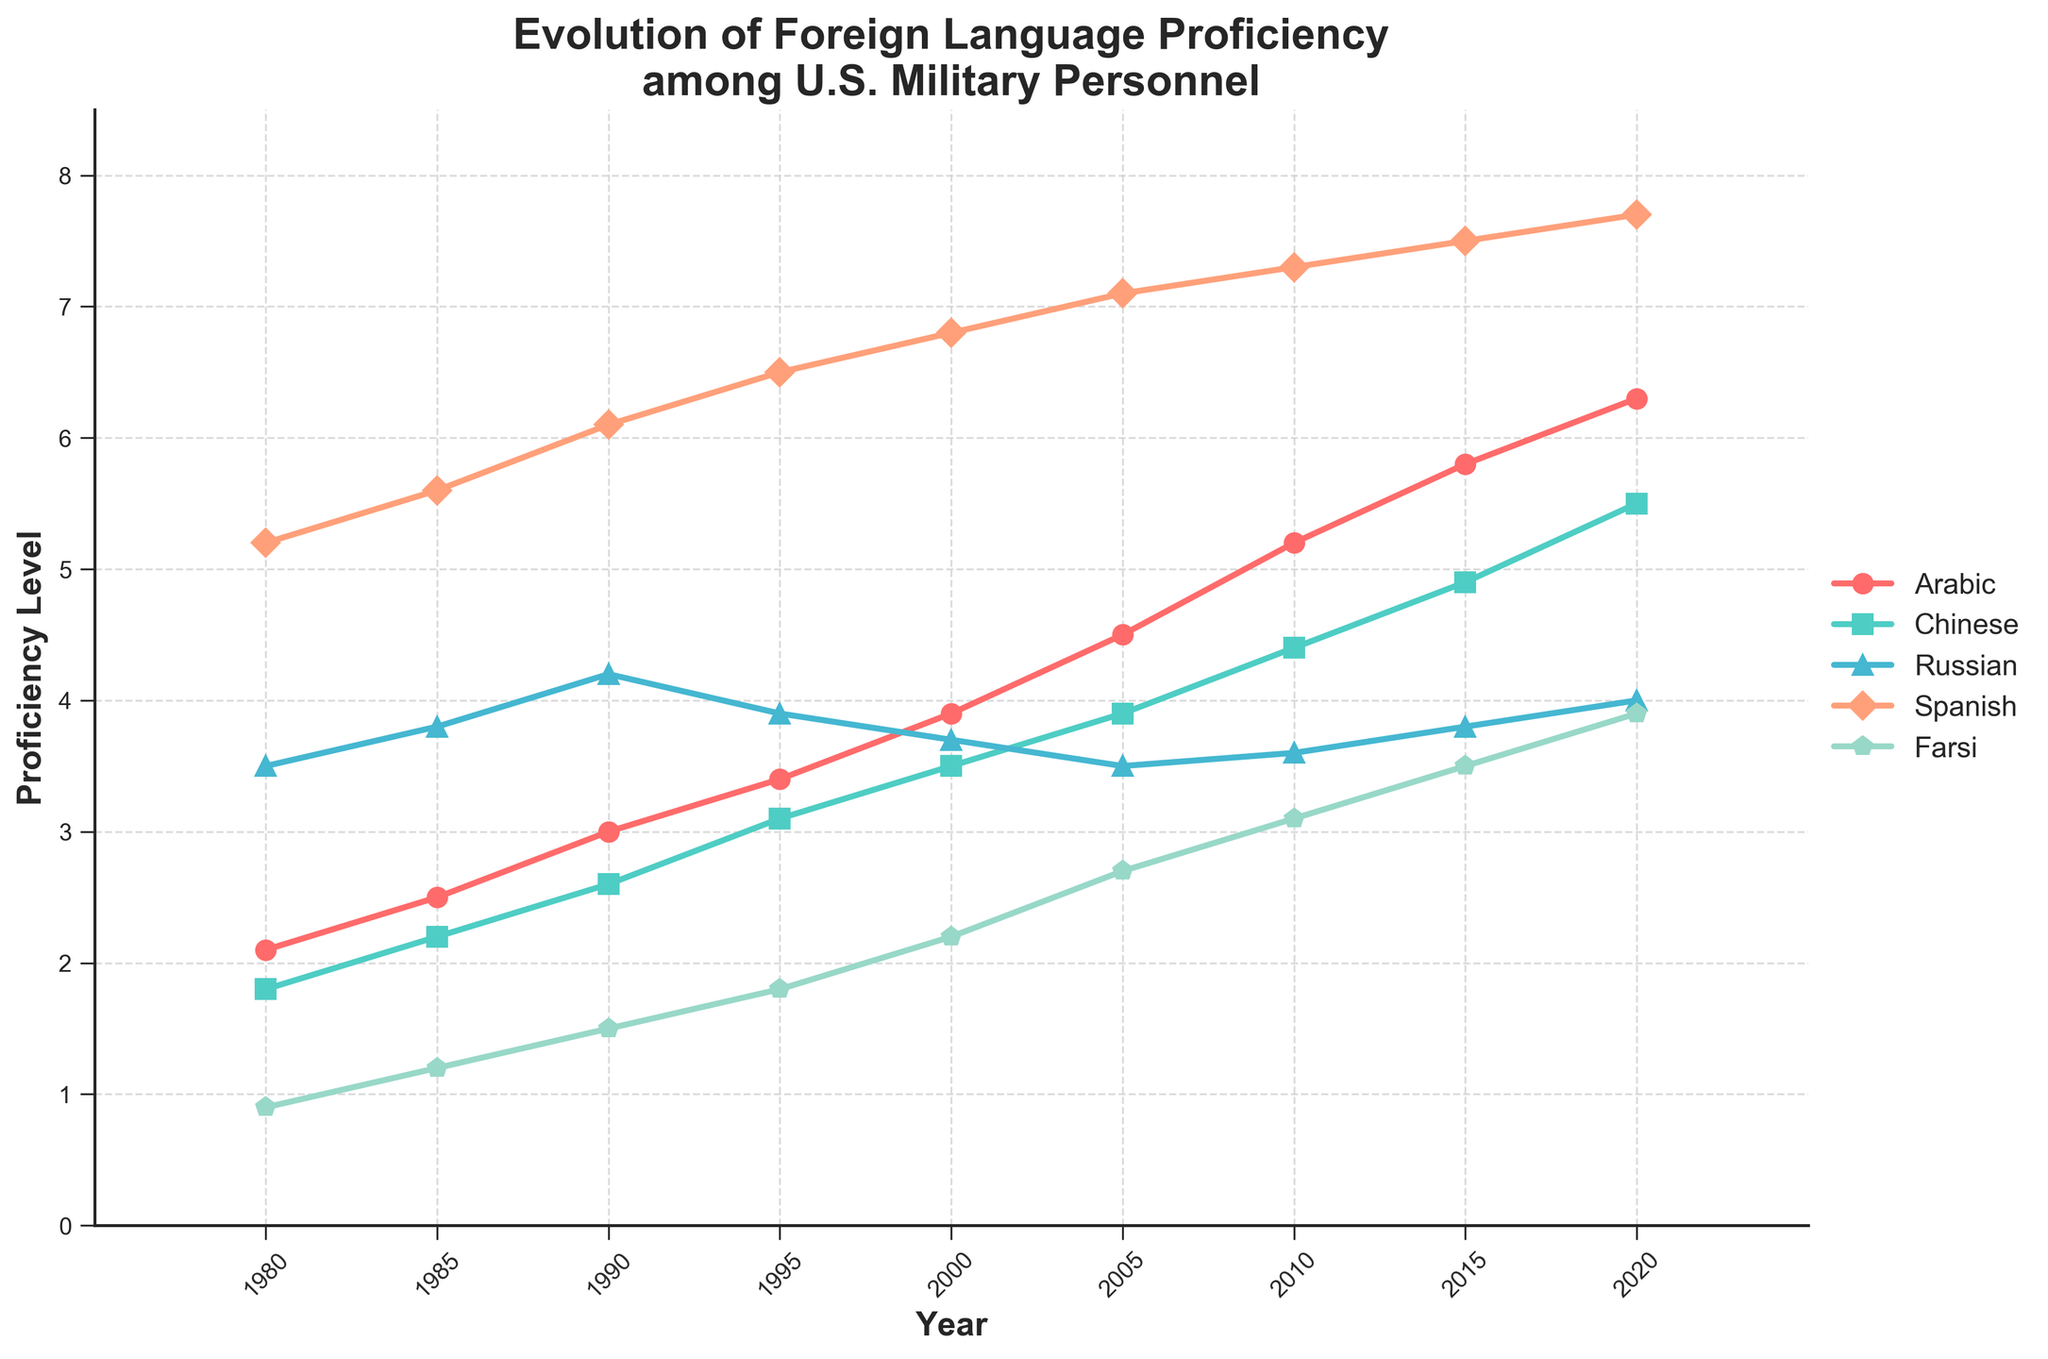What is the trend of Arabic language proficiency from 1980 to 2020? From the figure, follow the line representing Arabic from 1980 to 2020. The trend is increasing as the line moves upwards. The proficiency level starts at 2.1 in 1980 and rises steadily to 6.3 by 2020.
Answer: Increasing Which year had the highest Spanish language proficiency? Identify the peak value on the line representing Spanish proficiency. The highest proficiency occurs at the end of the period, which is 2020 with a value of 7.7.
Answer: 2020 Between 1990 and 2000, which language showed the greatest increase in proficiency? Calculate the difference between 2000 and 1990 for each language. Arabic: 3.9 - 3.0 = 0.9, Chinese: 3.5 - 2.6 = 0.9, Russian: 3.7 - 4.2 = -0.5, Spanish: 6.8 - 6.1 = 0.7, Farsi: 2.2 - 1.5 = 0.7. Both Arabic and Chinese show the greatest increase with 0.9.
Answer: Arabic, Chinese Is Farsi proficiency in 2020 greater than Chinese proficiency in 1990? Compare the Farsi value in 2020 (3.9) to the Chinese value in 1990 (2.6). Since 3.9 is greater than 2.6, Farsi proficiency in 2020 is indeed greater.
Answer: Yes Between 1980 and 2020, which language had the lowest overall increase in proficiency levels? Calculate the increase for each language from 1980 to 2020. Arabic: 6.3 - 2.1 = 4.2, Chinese: 5.5 - 1.8 = 3.7, Russian: 4.0 - 3.5 = 0.5, Spanish: 7.7 - 5.2 = 2.5, Farsi: 3.9 - 0.9 = 3.0. Russian shows the lowest increase of 0.5.
Answer: Russian What is the average proficiency level of Farsi from 1980 to 2020? Sum the Farsi proficiency levels (0.9, 1.2, 1.5, 1.8, 2.2, 2.7, 3.1, 3.5, 3.9) and divide by the number of data points (9). The sum is 20, so the average is 20/9.
Answer: 2.22 How does the trend in Chinese proficiency compare to Russian proficiency from 2000 to 2020? Observe both lines from 2000 to 2020. Chinese proficiency shows a steady increase from 3.5 to 5.5. Russian proficiency slightly fluctuates, starting at 3.7 in 2000, dropping and then ending at 4.0 in 2020. Chinese shows a clear increasing trend, while Russian shows minor fluctuation with a small upward trend.
Answer: Chinese increasing, Russian fluctuating Considering the trends, which language proficiency could potentially reach a level of 8 by 2025? Extend the current trends to predict future values. Arabic is increasing sharply and is at 6.3 in 2020, showing the potential to reach 8 by 2025 if the trend continues.
Answer: Arabic From 1990 to 2005, which language experienced a decrease in proficiency? Compare the proficiency levels between 1990 and 2005. Russian proficiency decreases from 4.2 in 1990 to 3.5 in 2005, while others increase or remain steady.
Answer: Russian 